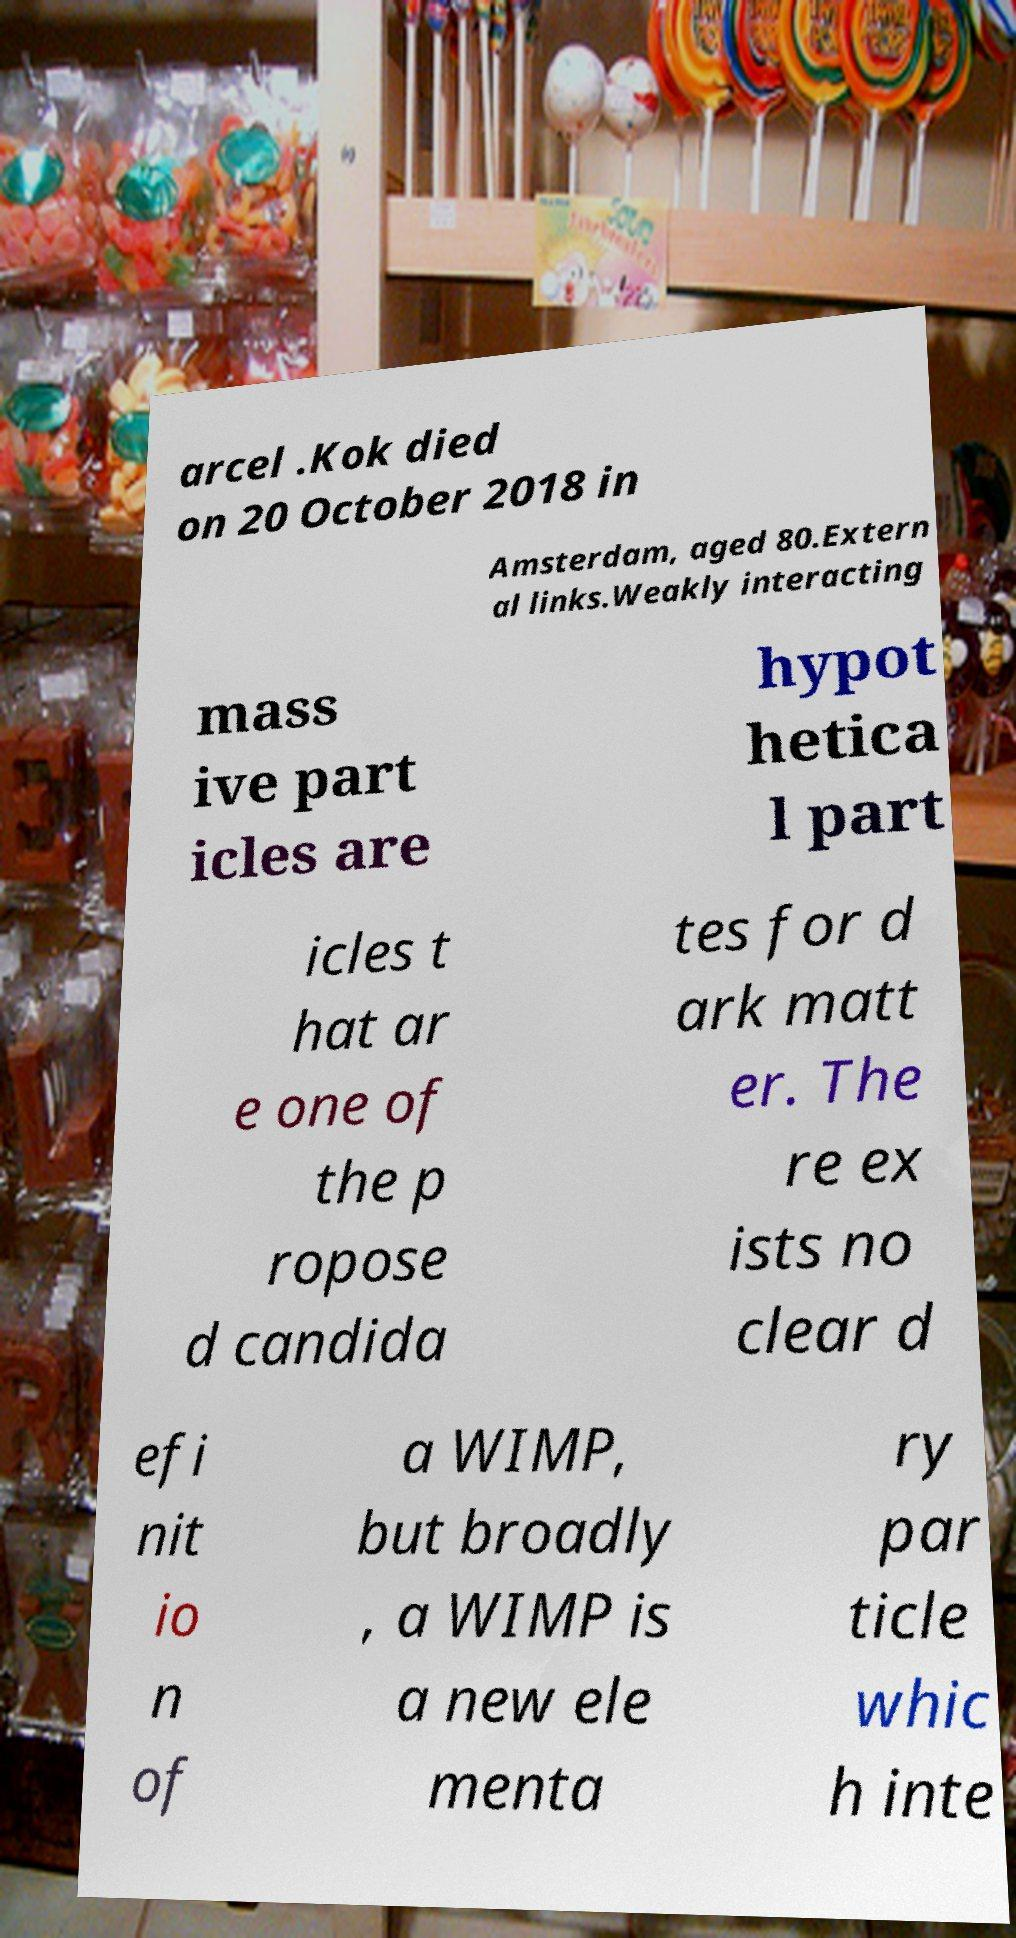What messages or text are displayed in this image? I need them in a readable, typed format. arcel .Kok died on 20 October 2018 in Amsterdam, aged 80.Extern al links.Weakly interacting mass ive part icles are hypot hetica l part icles t hat ar e one of the p ropose d candida tes for d ark matt er. The re ex ists no clear d efi nit io n of a WIMP, but broadly , a WIMP is a new ele menta ry par ticle whic h inte 